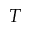<formula> <loc_0><loc_0><loc_500><loc_500>T</formula> 